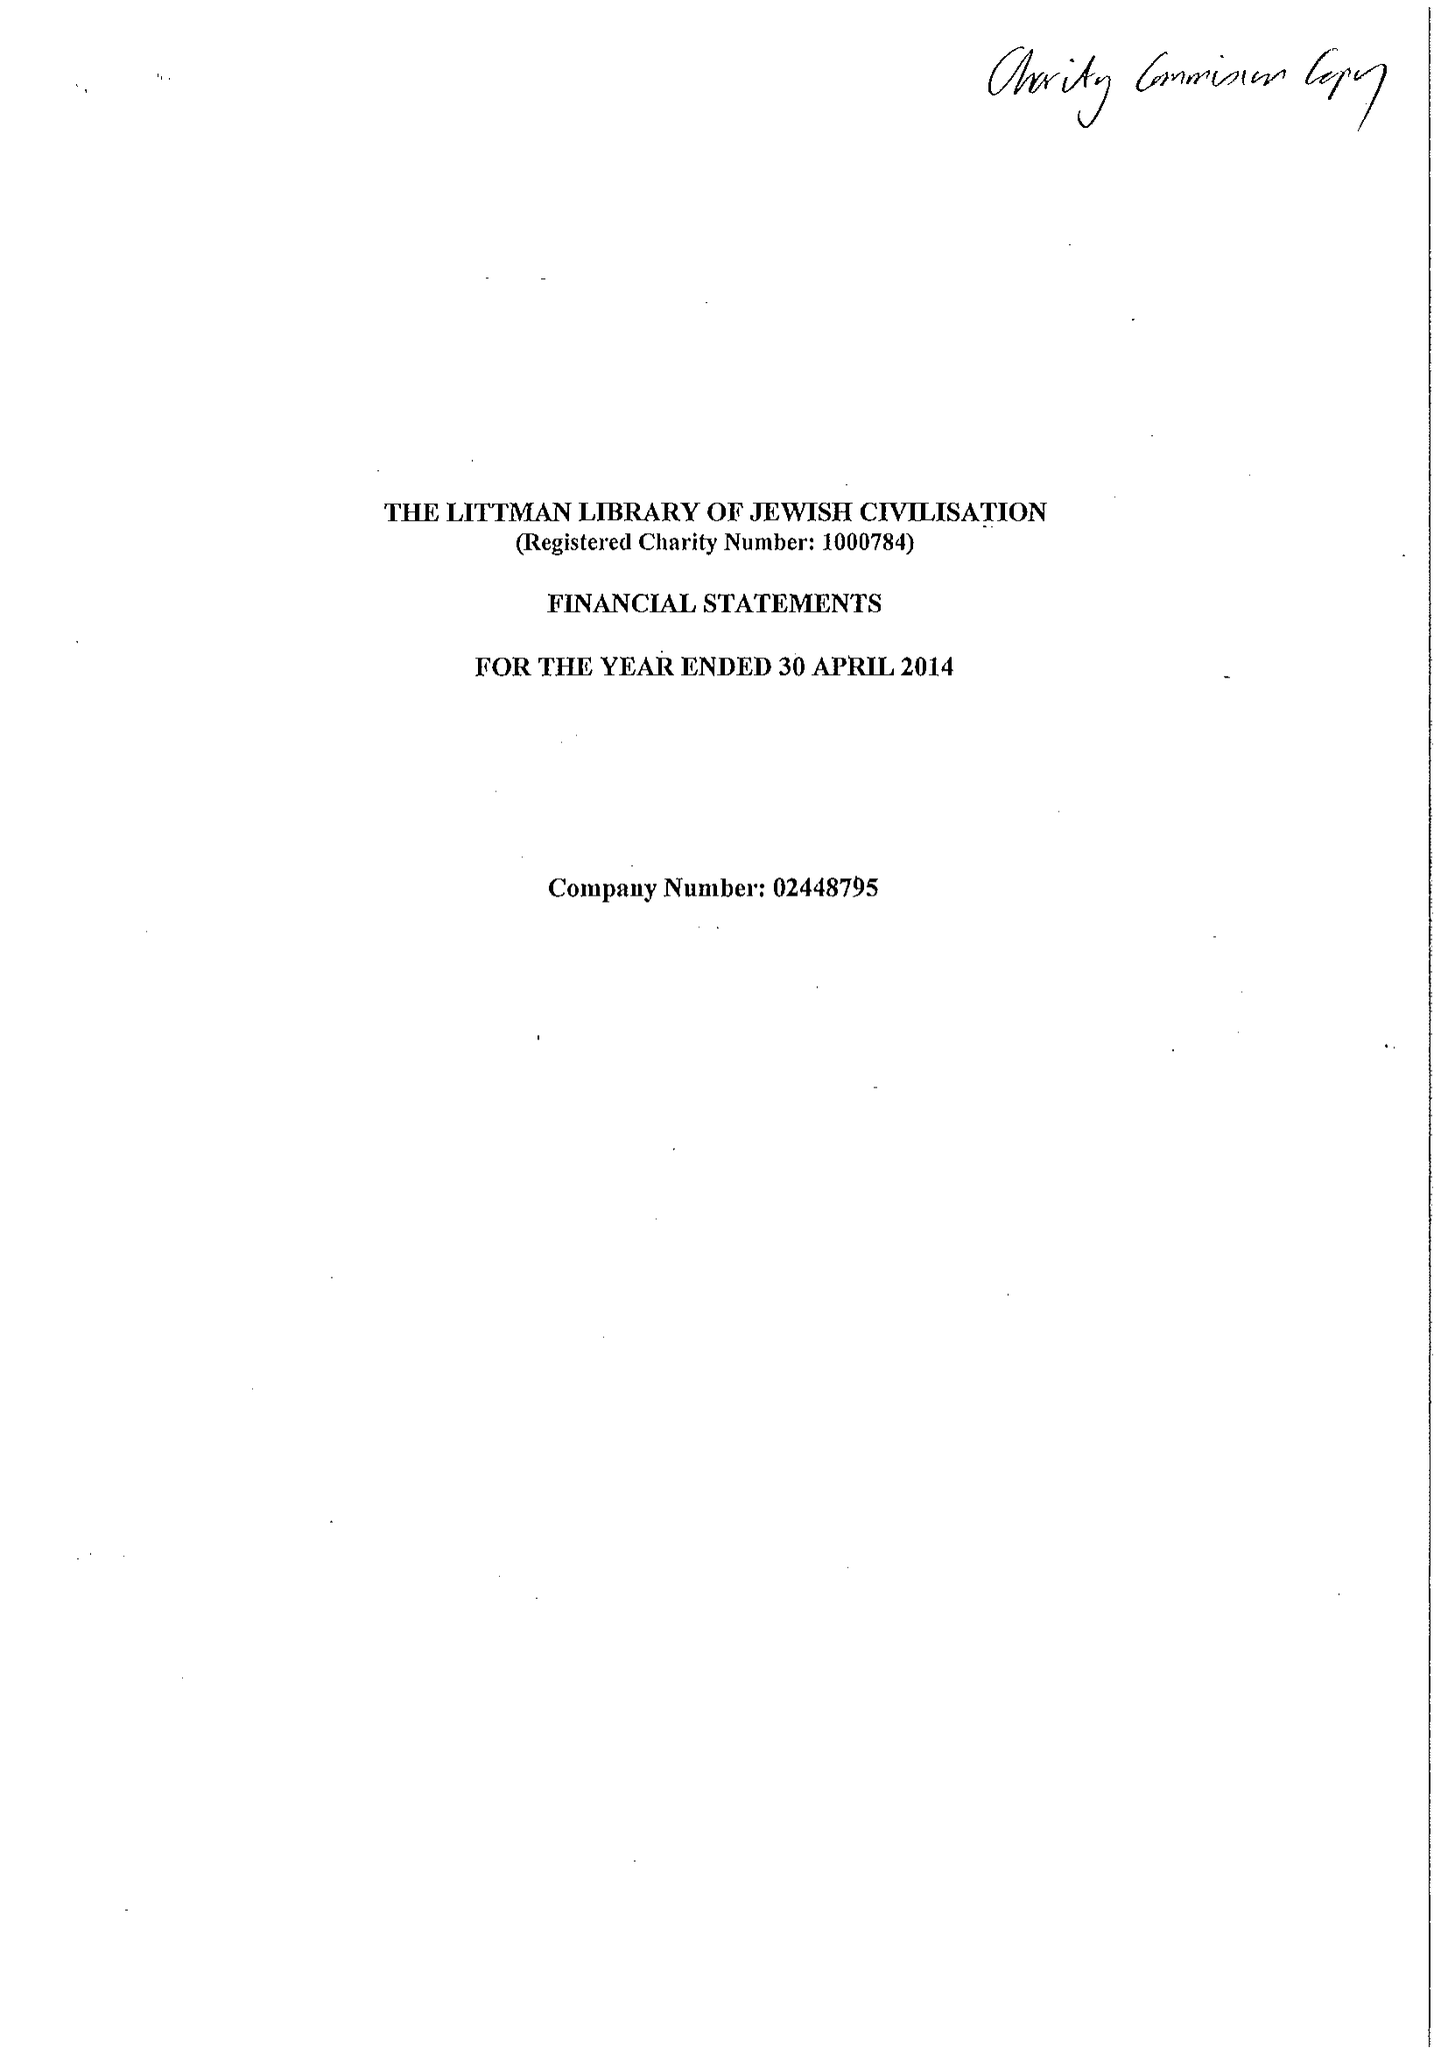What is the value for the spending_annually_in_british_pounds?
Answer the question using a single word or phrase. 255930.00 